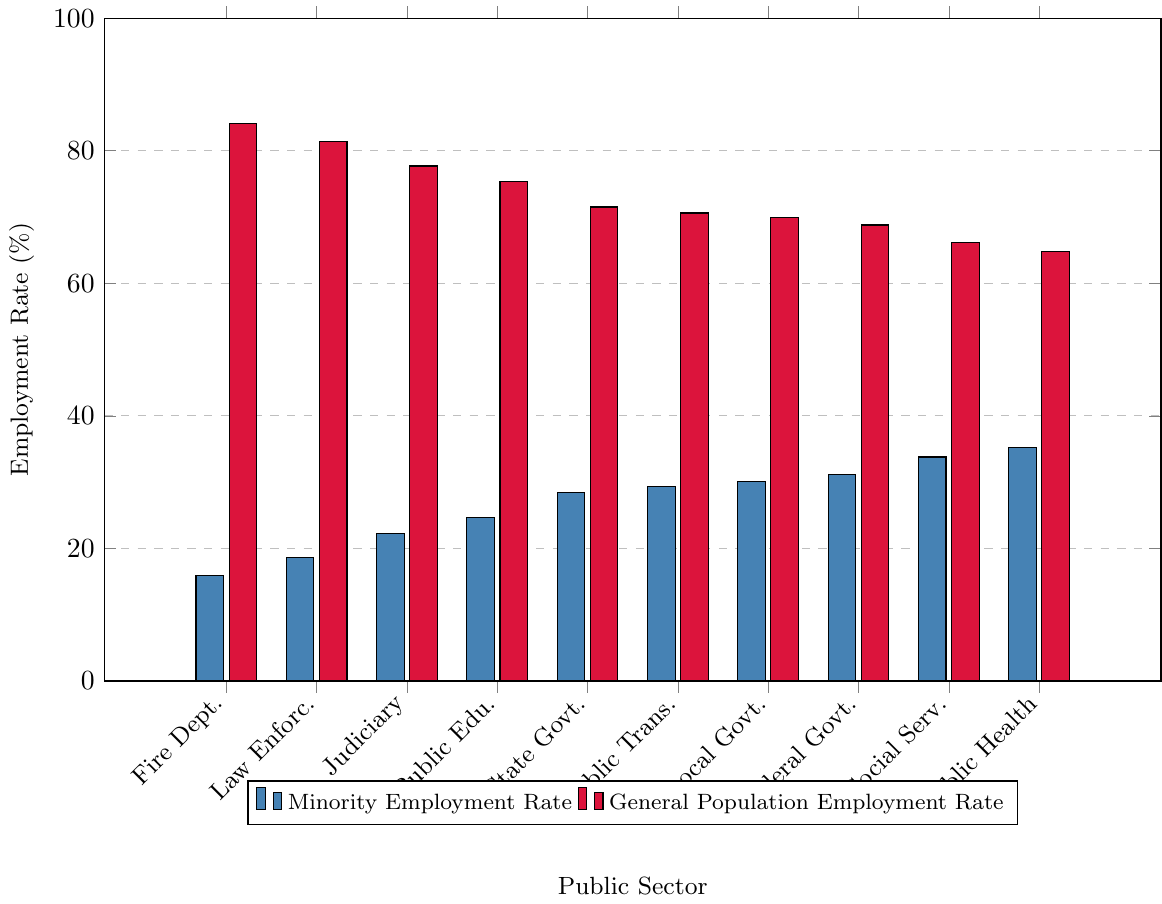what is the composite employment rate (minority and general population) for the Public Healthcare sector? The minority employment rate for the Public Healthcare sector is 35.2%, and the general population employment rate is 64.8%. Adding these percentages together gives 35.2 + 64.8 = 100%.
Answer: 100% Which sector has the highest minority employment rate and what percentage is it? By comparing the heights of the blue bars, the Public Healthcare sector has the highest minority employment rate at 35.2%.
Answer: Public Healthcare; 35.2% What is the difference in employment rates between the Fire Department for minorities and the general population? The employment rate for minorities in the Fire Department is 15.9%, and for the general population, it is 84.1%. The difference is 84.1% - 15.9% = 68.2%.
Answer: 68.2% Which sector has the smallest disparity between minority and general population employment rates? To find the smallest disparity, compare the differences for each sector. Public Healthcare shows the smallest disparity with a difference of 64.8% - 35.2% = 29.6%.
Answer: Public Healthcare How does the minority employment rate in Social Services compare to that in Law Enforcement? By comparing the heights of the blue bars, the minority employment rate in Social Services (33.8%) is higher than in Law Enforcement (18.6%).
Answer: Social Services has a higher rate What is the average employment rate for minorities in all sectors? Sum the minority employment rates of all sectors: 15.9 + 18.6 + 22.3 + 24.7 + 28.5 + 29.4 + 30.1 + 31.2 + 33.8 + 35.2 = 270.7. Divide by the number of sectors (10) to get the average: 270.7 / 10 = 27.07%.
Answer: 27.07% Which sectors have a minority employment rate below 20%? By examining the heights of the blue bars, the Fire Department (15.9%) and Law Enforcement (18.6%) have minority employment rates below 20%.
Answer: Fire Department, Law Enforcement What percentage of employment in the Federal Government sector is composed of the general population? The employment rate of the general population in the Federal Government sector is shown by the red bar, which is 68.8%.
Answer: 68.8% If you sum up the minority employment rates in State Government and Local Government, what total percentage do you get? Adding the minority employment rates for State Government (28.5%) and Local Government (30.1%) gives 28.5% + 30.1% = 58.6%.
Answer: 58.6% What is the median minority employment rate across all sectors? To find the median, list the minority employment rates in ascending order: 15.9, 18.6, 22.3, 24.7, 28.5, 29.4, 30.1, 31.2, 33.8, 35.2. The median is the average of the 5th and 6th values: (28.5 + 29.4) / 2 = 28.95%.
Answer: 28.95% 